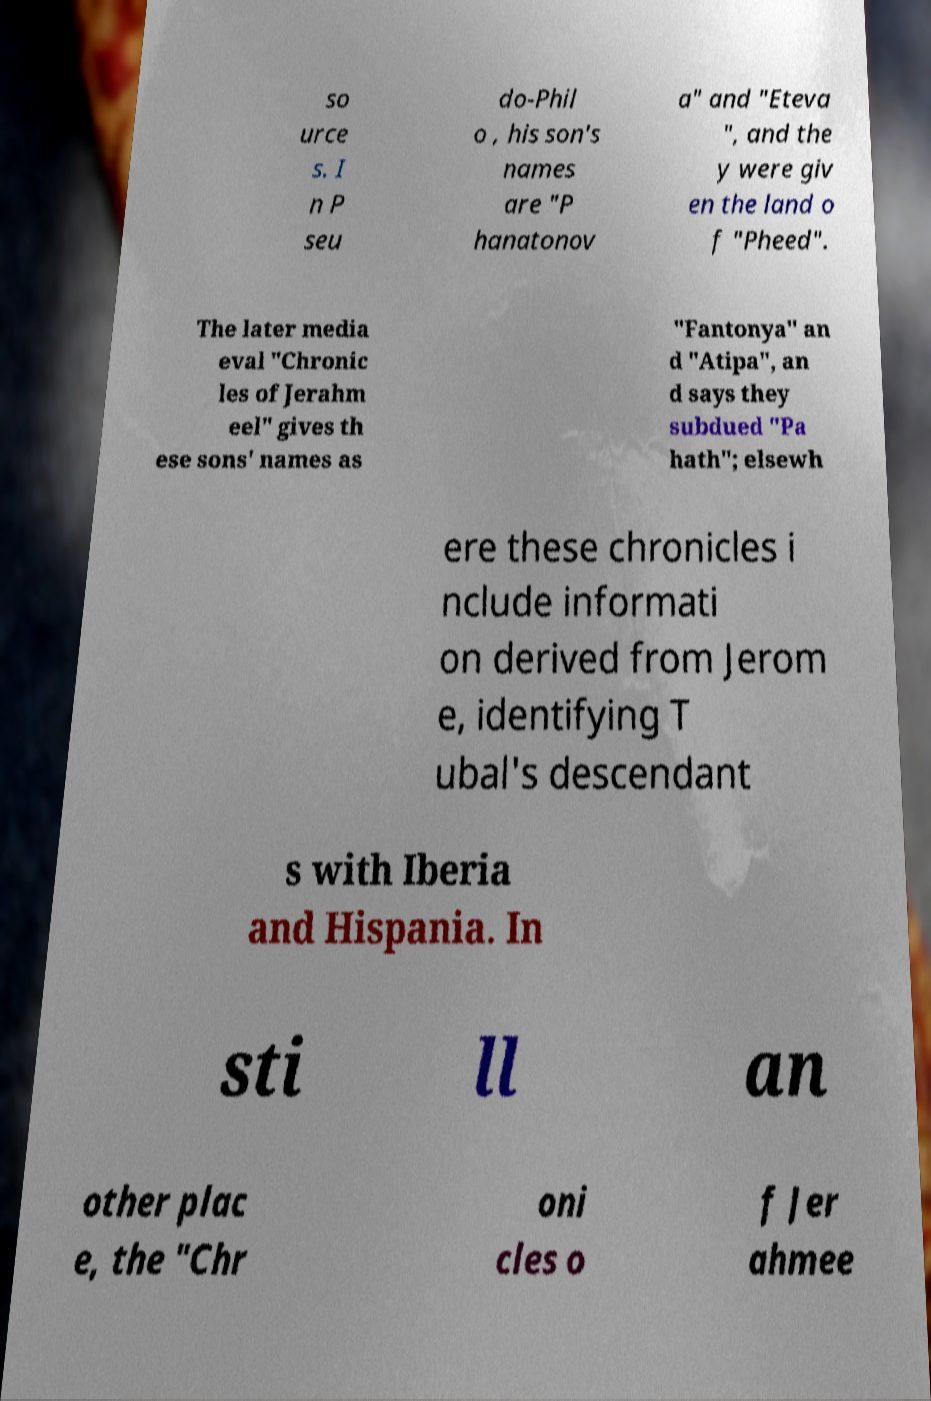What messages or text are displayed in this image? I need them in a readable, typed format. so urce s. I n P seu do-Phil o , his son's names are "P hanatonov a" and "Eteva ", and the y were giv en the land o f "Pheed". The later media eval "Chronic les of Jerahm eel" gives th ese sons' names as "Fantonya" an d "Atipa", an d says they subdued "Pa hath"; elsewh ere these chronicles i nclude informati on derived from Jerom e, identifying T ubal's descendant s with Iberia and Hispania. In sti ll an other plac e, the "Chr oni cles o f Jer ahmee 